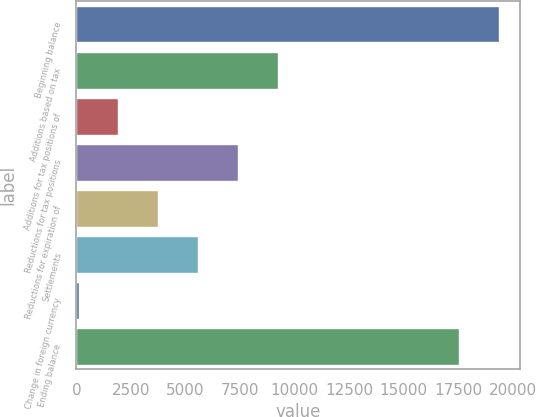Convert chart. <chart><loc_0><loc_0><loc_500><loc_500><bar_chart><fcel>Beginning balance<fcel>Additions based on tax<fcel>Additions for tax positions of<fcel>Reductions for tax positions<fcel>Reductions for expiration of<fcel>Settlements<fcel>Change in foreign currency<fcel>Ending balance<nl><fcel>19376.1<fcel>9224.5<fcel>1928.1<fcel>7400.4<fcel>3752.2<fcel>5576.3<fcel>104<fcel>17552<nl></chart> 